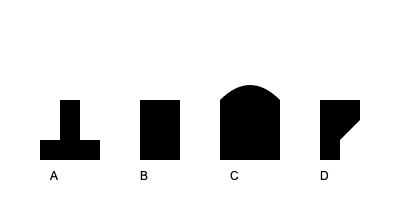Which silhouette represents an EMF (Electromagnetic Field) meter, a common tool used in ghost hunting? To identify the EMF meter, let's analyze each silhouette:

1. Silhouette A: This shape resembles a voice recorder or audio device, with a microphone-like top and a body for controls and storage.

2. Silhouette B: This rectangular shape with a consistent width is typical of a spirit box or radio scanner used for audio phenomena.

3. Silhouette C: This curved shape suggests a dowsing rod or pendulum, which some investigators use for detecting energy fields.

4. Silhouette D: This silhouette shows a device with a wider top that narrows towards the bottom, typically representing an EMF meter. The wider top often houses the sensor and display, while the narrower bottom serves as a handle.

EMF meters are designed to detect and measure electromagnetic fields, which some believe are associated with paranormal activity. The shape in silhouette D is consistent with handheld EMF meters commonly used in ghost hunting, featuring a sensor area at the top and a grip for easy handling.
Answer: D 